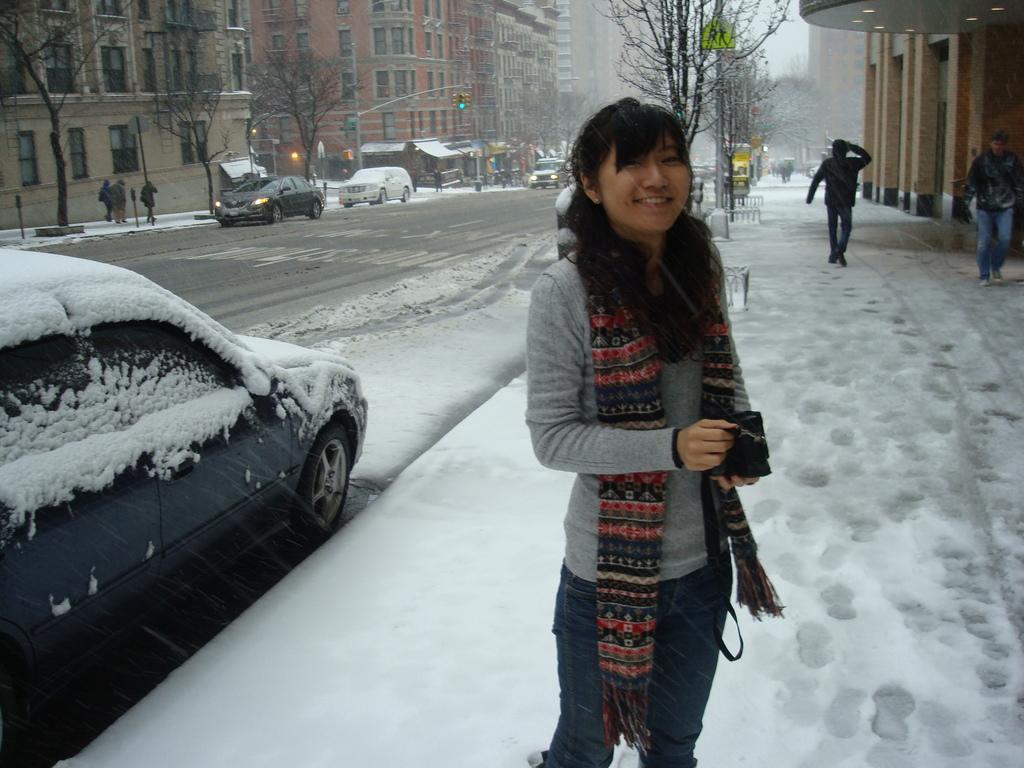Could you give a brief overview of what you see in this image? In front of the image there is a woman standing with a smile on her face, behind the woman on the pavement there are a few people walking, beside the pavement there are vehicles passing on the road, on the either side of the road there are trees, buildings, traffic lights and sign boards. 